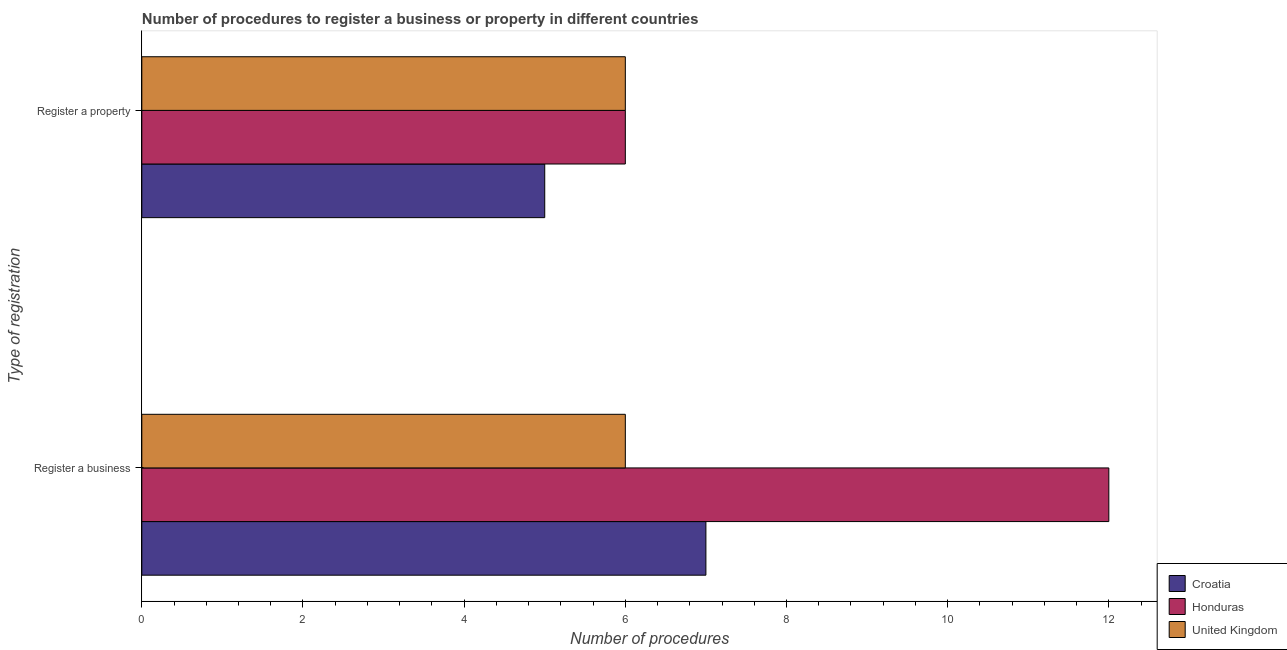How many groups of bars are there?
Your answer should be compact. 2. Are the number of bars per tick equal to the number of legend labels?
Keep it short and to the point. Yes. Are the number of bars on each tick of the Y-axis equal?
Provide a succinct answer. Yes. How many bars are there on the 2nd tick from the top?
Provide a short and direct response. 3. What is the label of the 2nd group of bars from the top?
Provide a succinct answer. Register a business. Across all countries, what is the maximum number of procedures to register a property?
Provide a succinct answer. 6. In which country was the number of procedures to register a business maximum?
Keep it short and to the point. Honduras. In which country was the number of procedures to register a property minimum?
Your answer should be compact. Croatia. What is the total number of procedures to register a property in the graph?
Offer a terse response. 17. What is the difference between the number of procedures to register a property in Croatia and that in Honduras?
Keep it short and to the point. -1. What is the difference between the number of procedures to register a property in United Kingdom and the number of procedures to register a business in Honduras?
Offer a very short reply. -6. What is the average number of procedures to register a business per country?
Offer a very short reply. 8.33. What is the difference between the number of procedures to register a property and number of procedures to register a business in United Kingdom?
Your answer should be very brief. 0. In how many countries, is the number of procedures to register a business greater than 5.2 ?
Ensure brevity in your answer.  3. What does the 2nd bar from the top in Register a business represents?
Provide a succinct answer. Honduras. What does the 2nd bar from the bottom in Register a property represents?
Your response must be concise. Honduras. How many countries are there in the graph?
Your answer should be very brief. 3. Are the values on the major ticks of X-axis written in scientific E-notation?
Keep it short and to the point. No. How many legend labels are there?
Give a very brief answer. 3. How are the legend labels stacked?
Make the answer very short. Vertical. What is the title of the graph?
Your answer should be very brief. Number of procedures to register a business or property in different countries. What is the label or title of the X-axis?
Your answer should be compact. Number of procedures. What is the label or title of the Y-axis?
Provide a succinct answer. Type of registration. What is the Number of procedures in United Kingdom in Register a business?
Your answer should be compact. 6. What is the Number of procedures in Honduras in Register a property?
Your answer should be very brief. 6. What is the Number of procedures in United Kingdom in Register a property?
Provide a succinct answer. 6. Across all Type of registration, what is the maximum Number of procedures in United Kingdom?
Give a very brief answer. 6. Across all Type of registration, what is the minimum Number of procedures in Croatia?
Your answer should be very brief. 5. Across all Type of registration, what is the minimum Number of procedures in United Kingdom?
Keep it short and to the point. 6. What is the difference between the Number of procedures in Croatia in Register a business and that in Register a property?
Your answer should be compact. 2. What is the difference between the Number of procedures of United Kingdom in Register a business and that in Register a property?
Provide a short and direct response. 0. What is the difference between the Number of procedures of Croatia in Register a business and the Number of procedures of United Kingdom in Register a property?
Provide a short and direct response. 1. What is the difference between the Number of procedures in Honduras in Register a business and the Number of procedures in United Kingdom in Register a property?
Your response must be concise. 6. What is the average Number of procedures in Honduras per Type of registration?
Make the answer very short. 9. What is the difference between the Number of procedures in Croatia and Number of procedures in United Kingdom in Register a business?
Your response must be concise. 1. What is the difference between the Number of procedures in Croatia and Number of procedures in Honduras in Register a property?
Offer a terse response. -1. What is the difference between the Number of procedures of Croatia and Number of procedures of United Kingdom in Register a property?
Provide a short and direct response. -1. What is the ratio of the Number of procedures in Croatia in Register a business to that in Register a property?
Give a very brief answer. 1.4. What is the ratio of the Number of procedures in United Kingdom in Register a business to that in Register a property?
Keep it short and to the point. 1. What is the difference between the highest and the lowest Number of procedures of Honduras?
Keep it short and to the point. 6. What is the difference between the highest and the lowest Number of procedures in United Kingdom?
Your response must be concise. 0. 